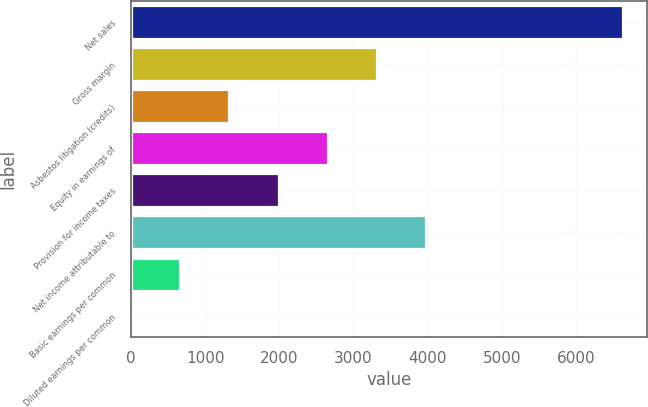Convert chart. <chart><loc_0><loc_0><loc_500><loc_500><bar_chart><fcel>Net sales<fcel>Gross margin<fcel>Asbestos litigation (credits)<fcel>Equity in earnings of<fcel>Provision for income taxes<fcel>Net income attributable to<fcel>Basic earnings per common<fcel>Diluted earnings per common<nl><fcel>6632<fcel>3317.13<fcel>1328.2<fcel>2654.16<fcel>1991.18<fcel>3980.11<fcel>665.23<fcel>2.25<nl></chart> 